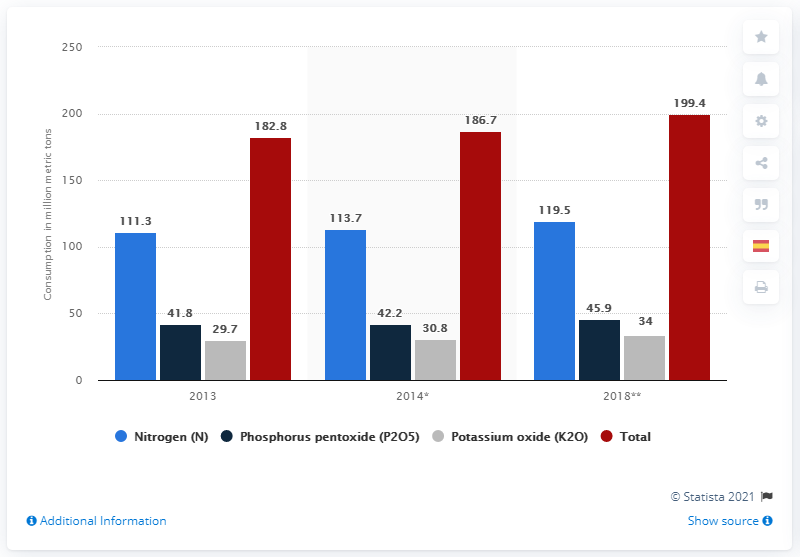Draw attention to some important aspects in this diagram. In 2013, the global consumption of fertilizer by nutrient reached 111.3 megatons. 